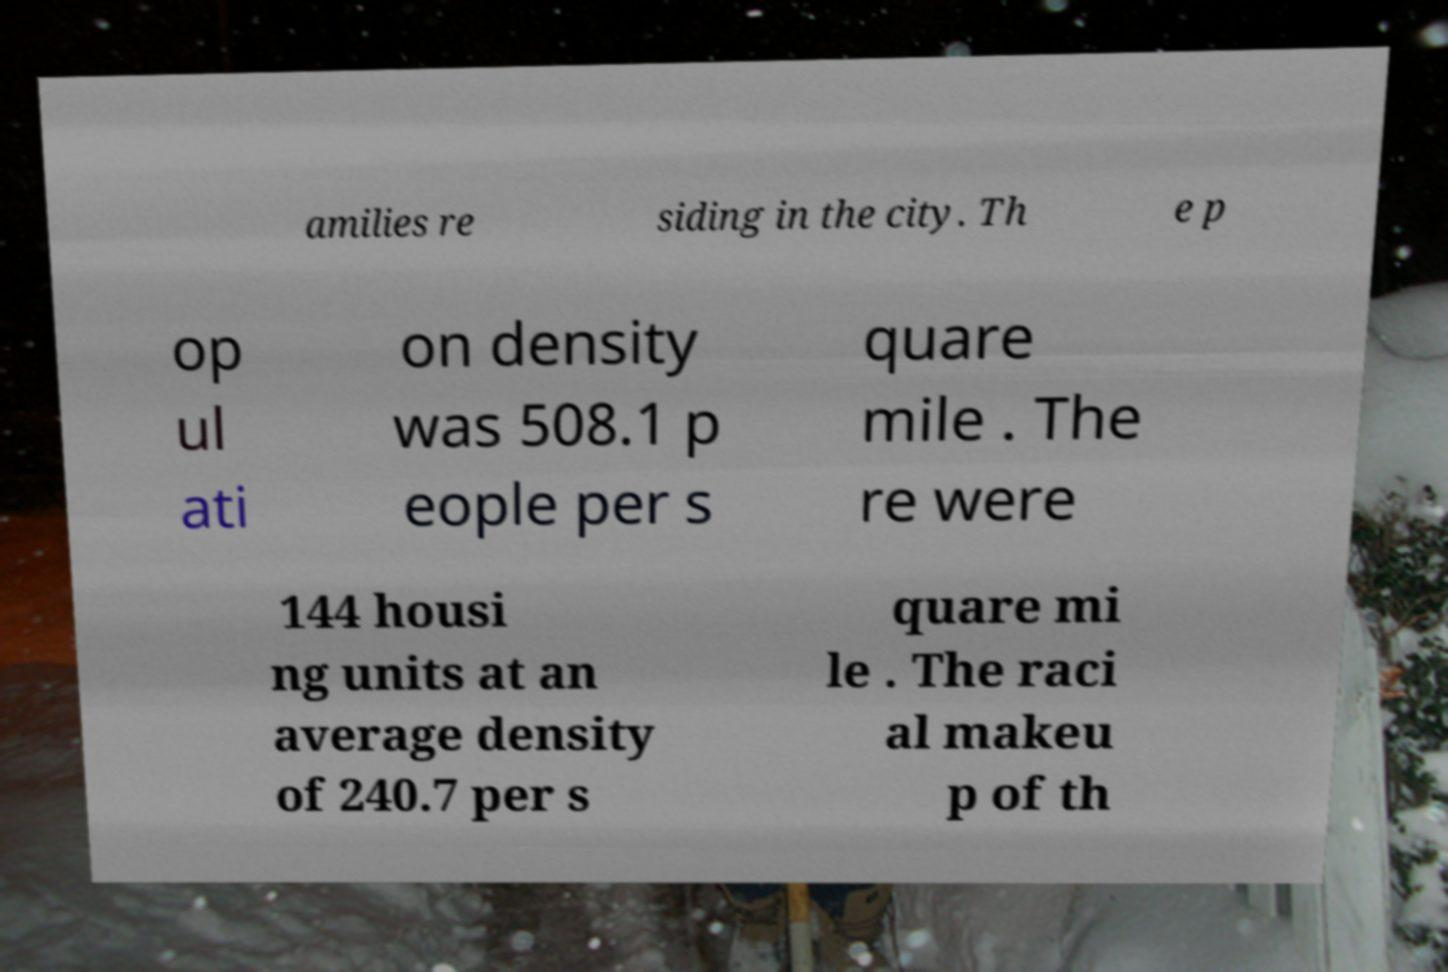I need the written content from this picture converted into text. Can you do that? amilies re siding in the city. Th e p op ul ati on density was 508.1 p eople per s quare mile . The re were 144 housi ng units at an average density of 240.7 per s quare mi le . The raci al makeu p of th 